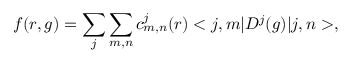<formula> <loc_0><loc_0><loc_500><loc_500>f ( r , g ) = \sum _ { j } \sum _ { m , n } c _ { m , n } ^ { j } ( r ) < j , m | D ^ { j } ( g ) | j , n > ,</formula> 